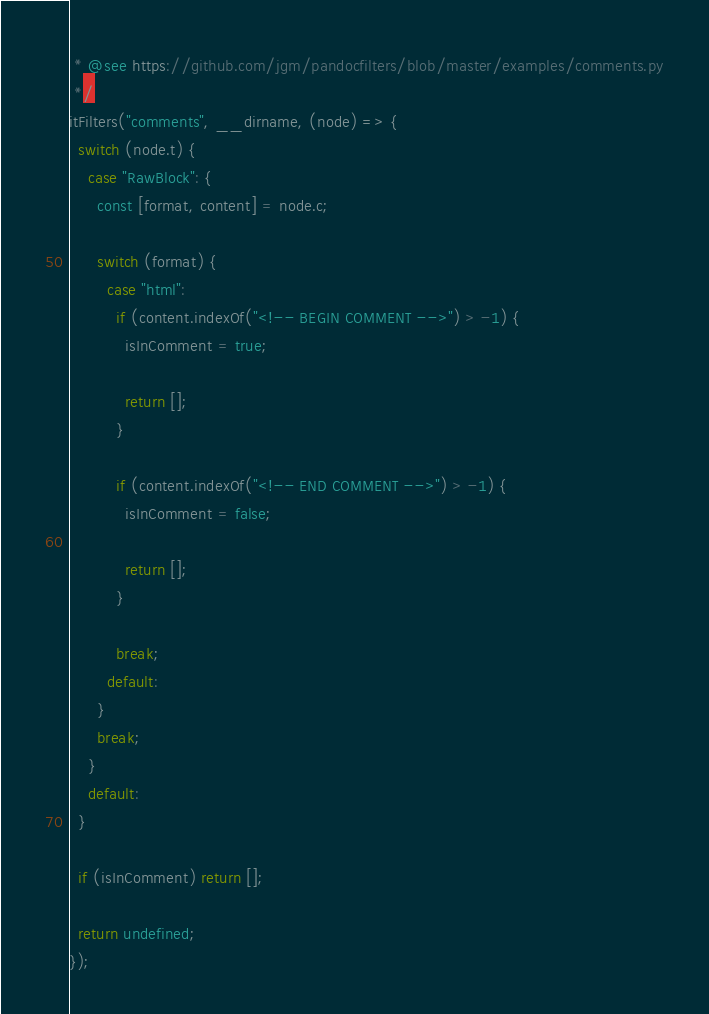<code> <loc_0><loc_0><loc_500><loc_500><_TypeScript_> * @see https://github.com/jgm/pandocfilters/blob/master/examples/comments.py
 */
itFilters("comments", __dirname, (node) => {
  switch (node.t) {
    case "RawBlock": {
      const [format, content] = node.c;

      switch (format) {
        case "html":
          if (content.indexOf("<!-- BEGIN COMMENT -->") > -1) {
            isInComment = true;

            return [];
          }

          if (content.indexOf("<!-- END COMMENT -->") > -1) {
            isInComment = false;

            return [];
          }

          break;
        default:
      }
      break;
    }
    default:
  }

  if (isInComment) return [];

  return undefined;
});
</code> 